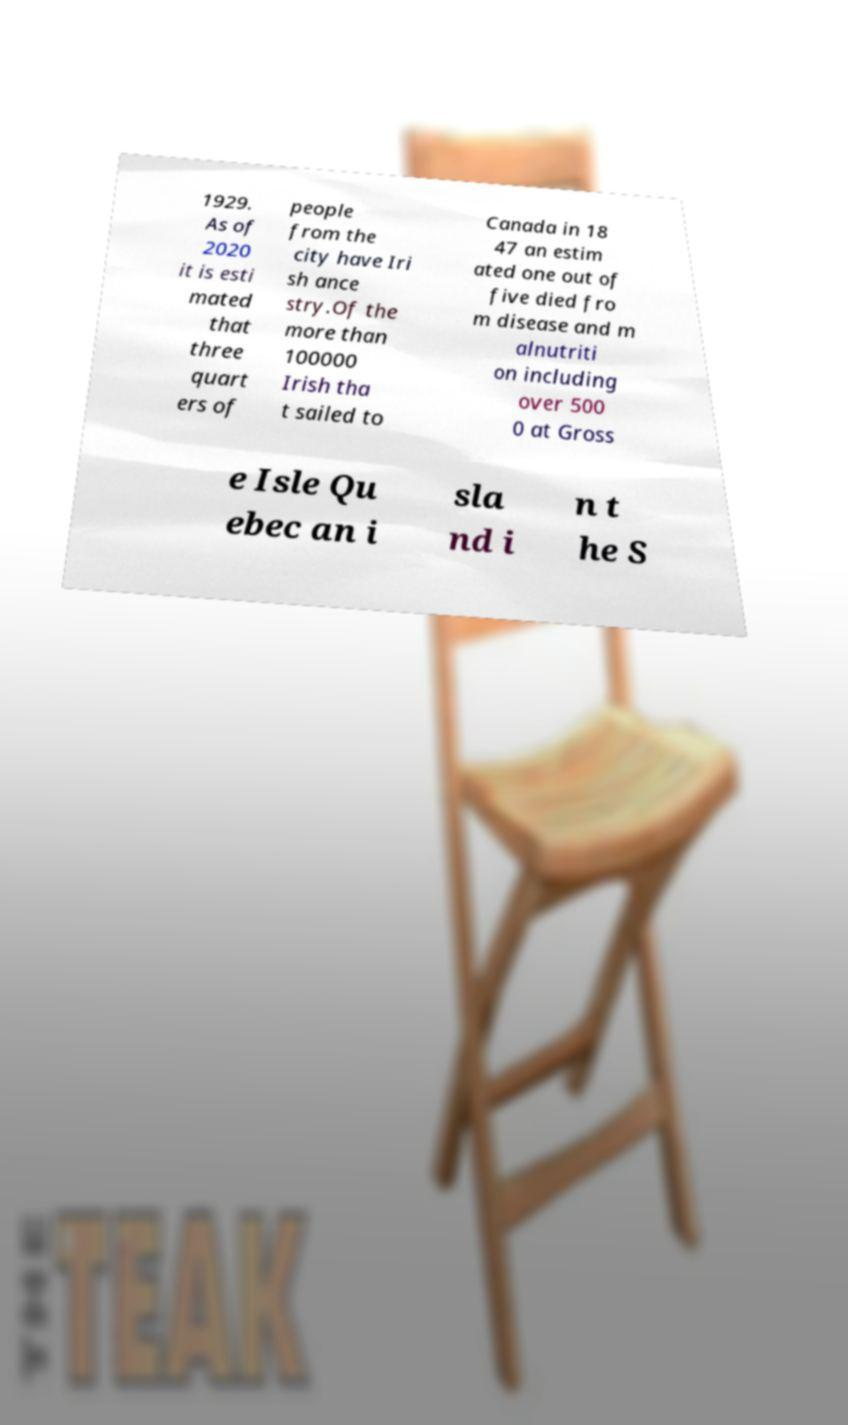Can you read and provide the text displayed in the image?This photo seems to have some interesting text. Can you extract and type it out for me? 1929. As of 2020 it is esti mated that three quart ers of people from the city have Iri sh ance stry.Of the more than 100000 Irish tha t sailed to Canada in 18 47 an estim ated one out of five died fro m disease and m alnutriti on including over 500 0 at Gross e Isle Qu ebec an i sla nd i n t he S 